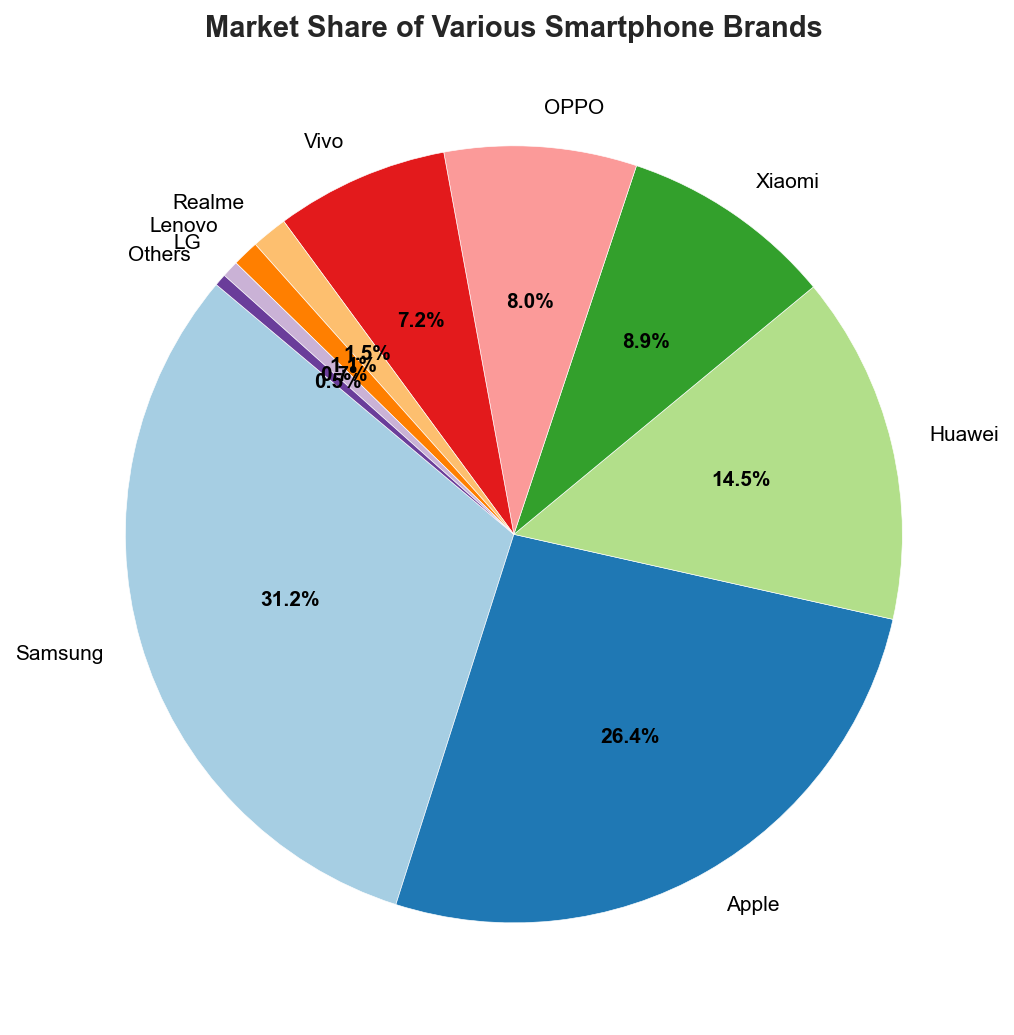What is the market share of the brand with the smallest percentage? The smallest percentage on the pie chart is 0.5%, associated with the "Others" category.
Answer: 0.5% Which two brands have the closest market shares, and what are they? By comparing the market shares, Vivo (7.2%) and Realme (1.5%) have the closest relative percentage, but the closest large values are between OPPO (8.0%) and Xiaomi (8.9%), which are close visually and arithmetically (0.9% difference).
Answer: OPPO and Xiaomi What is the combined market share of the top three brands? The top three brands by market share are Samsung, Apple, and Huawei. Their combined market share is 31.2% + 26.4% + 14.5% = 72.1%.
Answer: 72.1% How much larger is Samsung's market share compared to LG's? The market share of Samsung is 31.2% and LG is 0.7%. The difference is 31.2% - 0.7% = 30.5%.
Answer: 30.5% What market share percentage do brands with less than 10% each sum up to? Adding up the market share of brands with less than 10% each: Huawei (14.5%, excluded), Xiaomi (8.9%), OPPO (8.0%), Vivo (7.2%), Realme (1.5%), Lenovo (1.1%), LG (0.7%), Others (0.5%). Sum is 8.9 + 8.0 + 7.2 + 1.5 + 1.1 + 0.7 + 0.5 = 27.9%.
Answer: 27.9% Which brand has the second highest market share, and what is its value? Apple has the second highest market share at 26.4%, as indicated by the second-largest wedge on the pie chart.
Answer: Apple, 26.4% What is the total market share of Huawei and Vivo combined? Huawei has 14.5% and Vivo has 7.2%. Their combined share is 14.5% + 7.2% = 21.7%.
Answer: 21.7% If the market share of the "Others" category doubled, what would the new total market share be for that category? Doubling the "Others" category market share: 0.5% * 2 = 1.0%.
Answer: 1.0% What is the average market share of Xiaomi, OPPO, and Vivo? Calculating the average: (8.9% + 8.0% + 7.2%) / 3 = 8.0333%, rounded to 8.0%.
Answer: 8.0% Which brand segments are represented by the smallest wedges in the pie chart? The smallest wedges, based on the visual proportion, correspond to Realme, Lenovo, LG, and Others.
Answer: Realme, Lenovo, LG, Others 